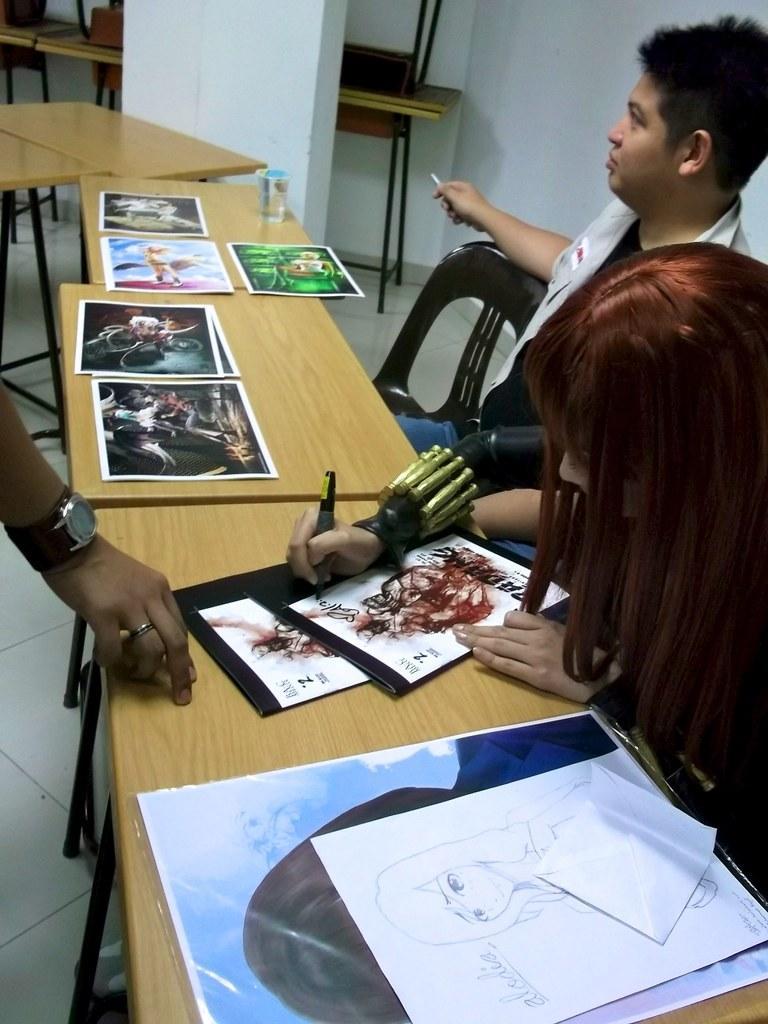How would you summarize this image in a sentence or two? In the picture we can see some tables and near it, we can see a man and a woman and woman is drawing something on the paper and opposite to her we can see a person's hand on the table and beside the tables we can see the pillar and behind the pillar also we can see some tables one on the other near the wall. 